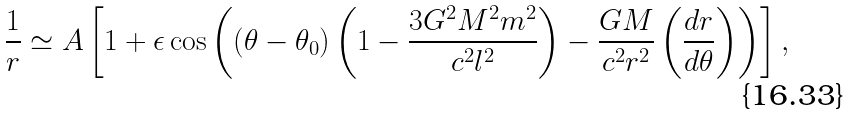Convert formula to latex. <formula><loc_0><loc_0><loc_500><loc_500>\frac { 1 } { r } \simeq A \left [ 1 + \epsilon \cos \left ( ( \theta - \theta _ { 0 } ) \left ( 1 - \frac { 3 G ^ { 2 } M ^ { 2 } m ^ { 2 } } { c ^ { 2 } l ^ { 2 } } \right ) - \frac { G M } { c ^ { 2 } r ^ { 2 } } \left ( \frac { d r } { d \theta } \right ) \right ) \right ] ,</formula> 